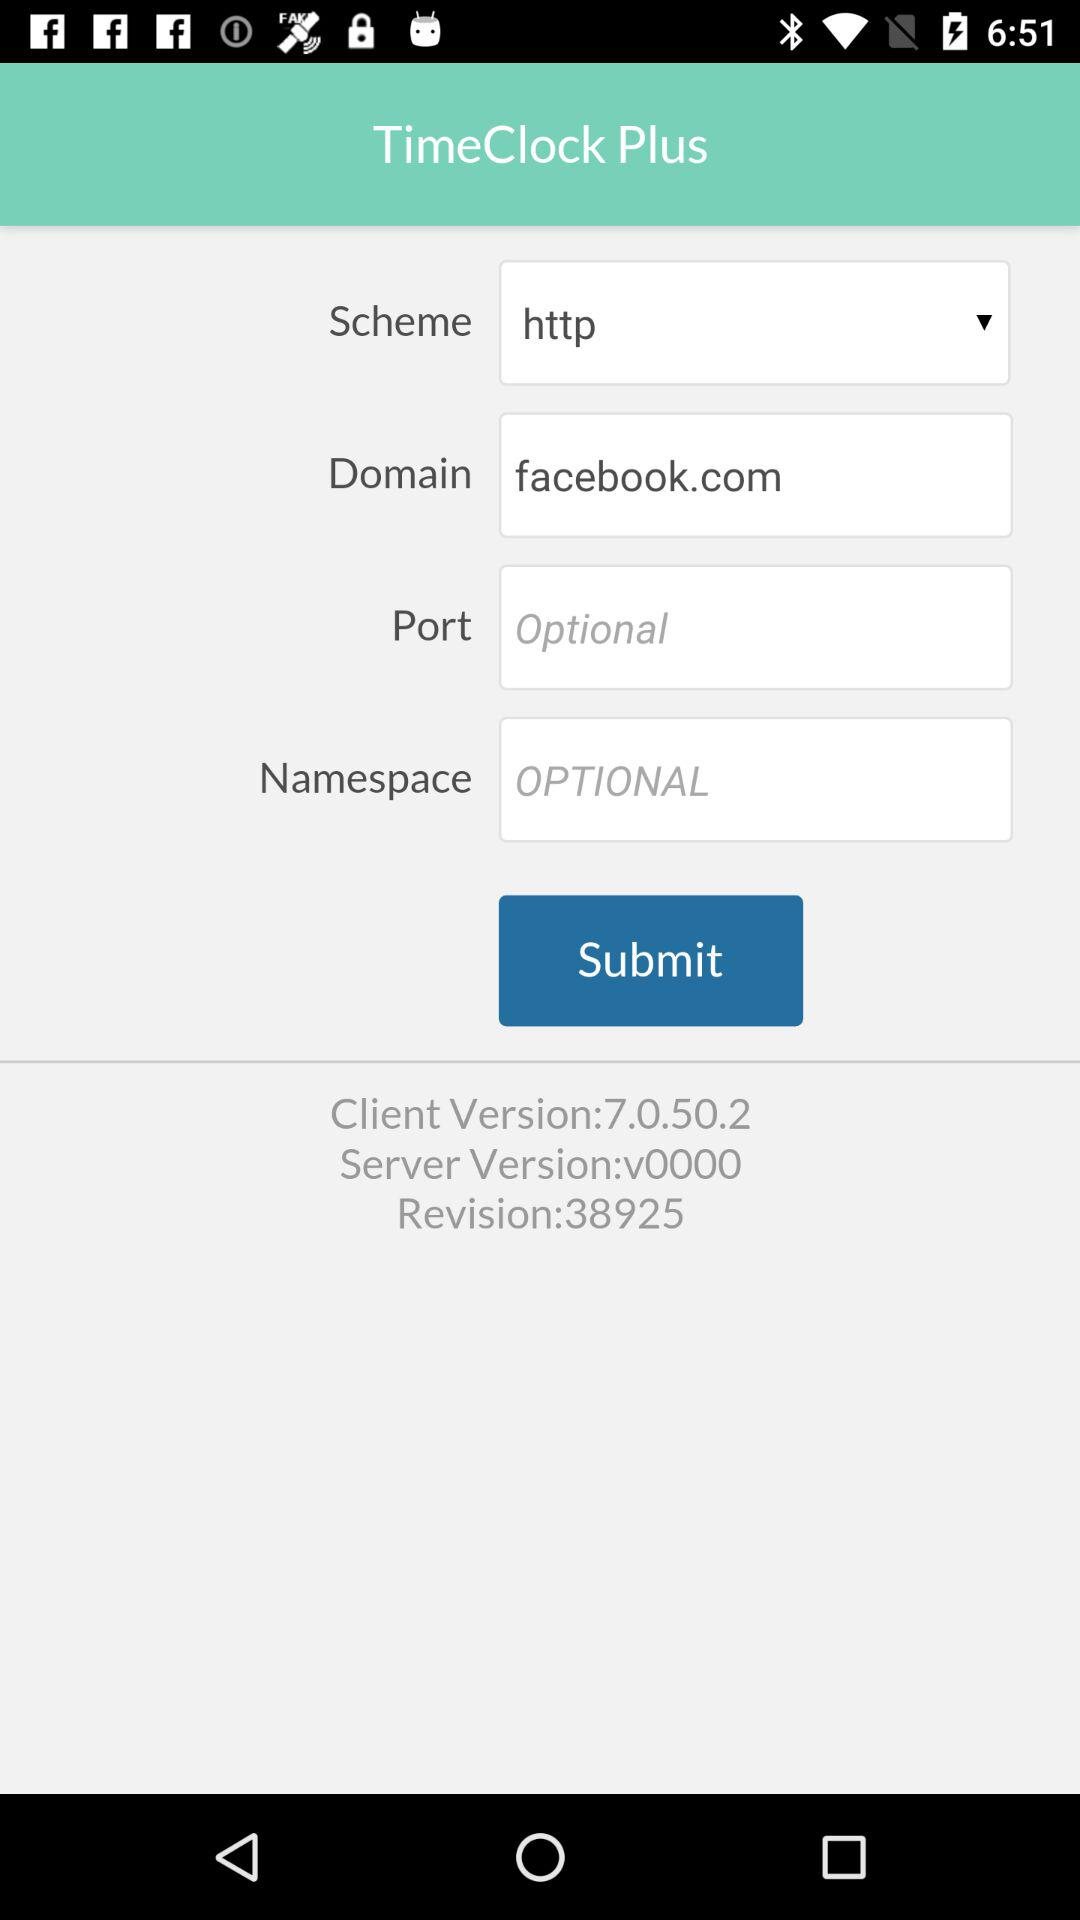What is the domain name? The domain name is facebook.com. 